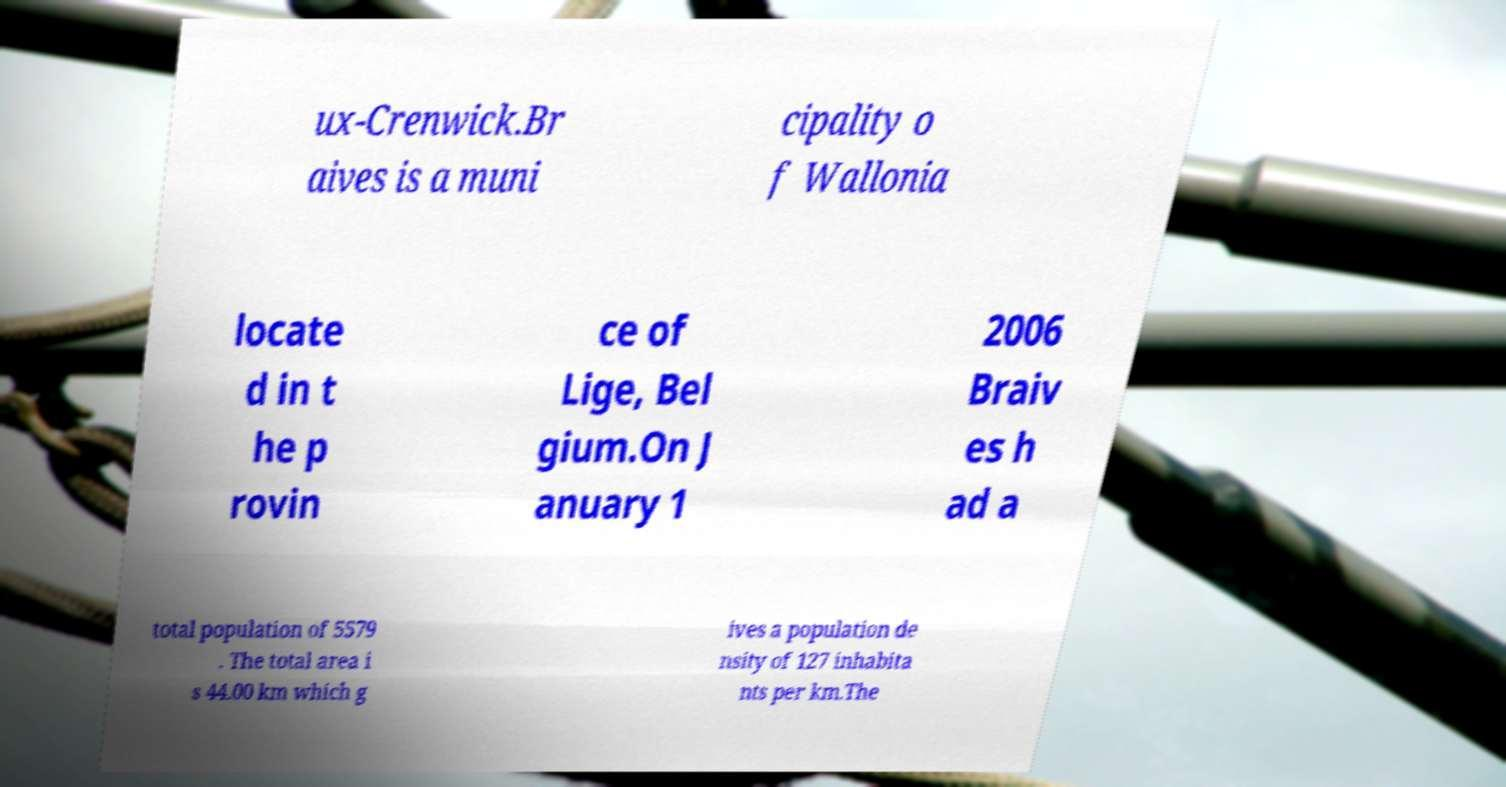Can you read and provide the text displayed in the image?This photo seems to have some interesting text. Can you extract and type it out for me? ux-Crenwick.Br aives is a muni cipality o f Wallonia locate d in t he p rovin ce of Lige, Bel gium.On J anuary 1 2006 Braiv es h ad a total population of 5579 . The total area i s 44.00 km which g ives a population de nsity of 127 inhabita nts per km.The 